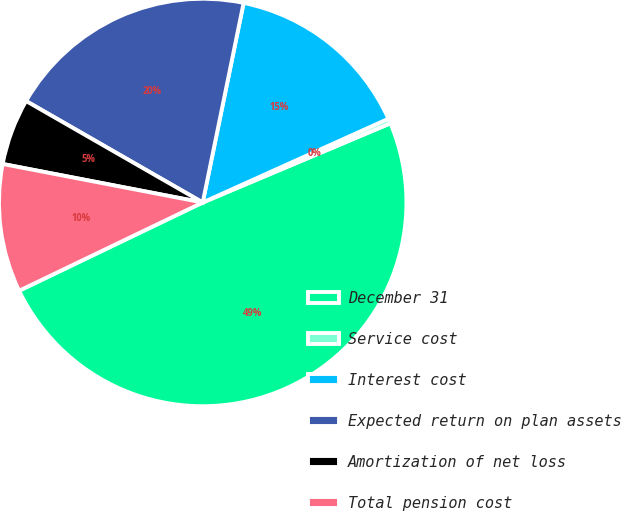<chart> <loc_0><loc_0><loc_500><loc_500><pie_chart><fcel>December 31<fcel>Service cost<fcel>Interest cost<fcel>Expected return on plan assets<fcel>Amortization of net loss<fcel>Total pension cost<nl><fcel>49.22%<fcel>0.39%<fcel>15.04%<fcel>19.92%<fcel>5.27%<fcel>10.16%<nl></chart> 